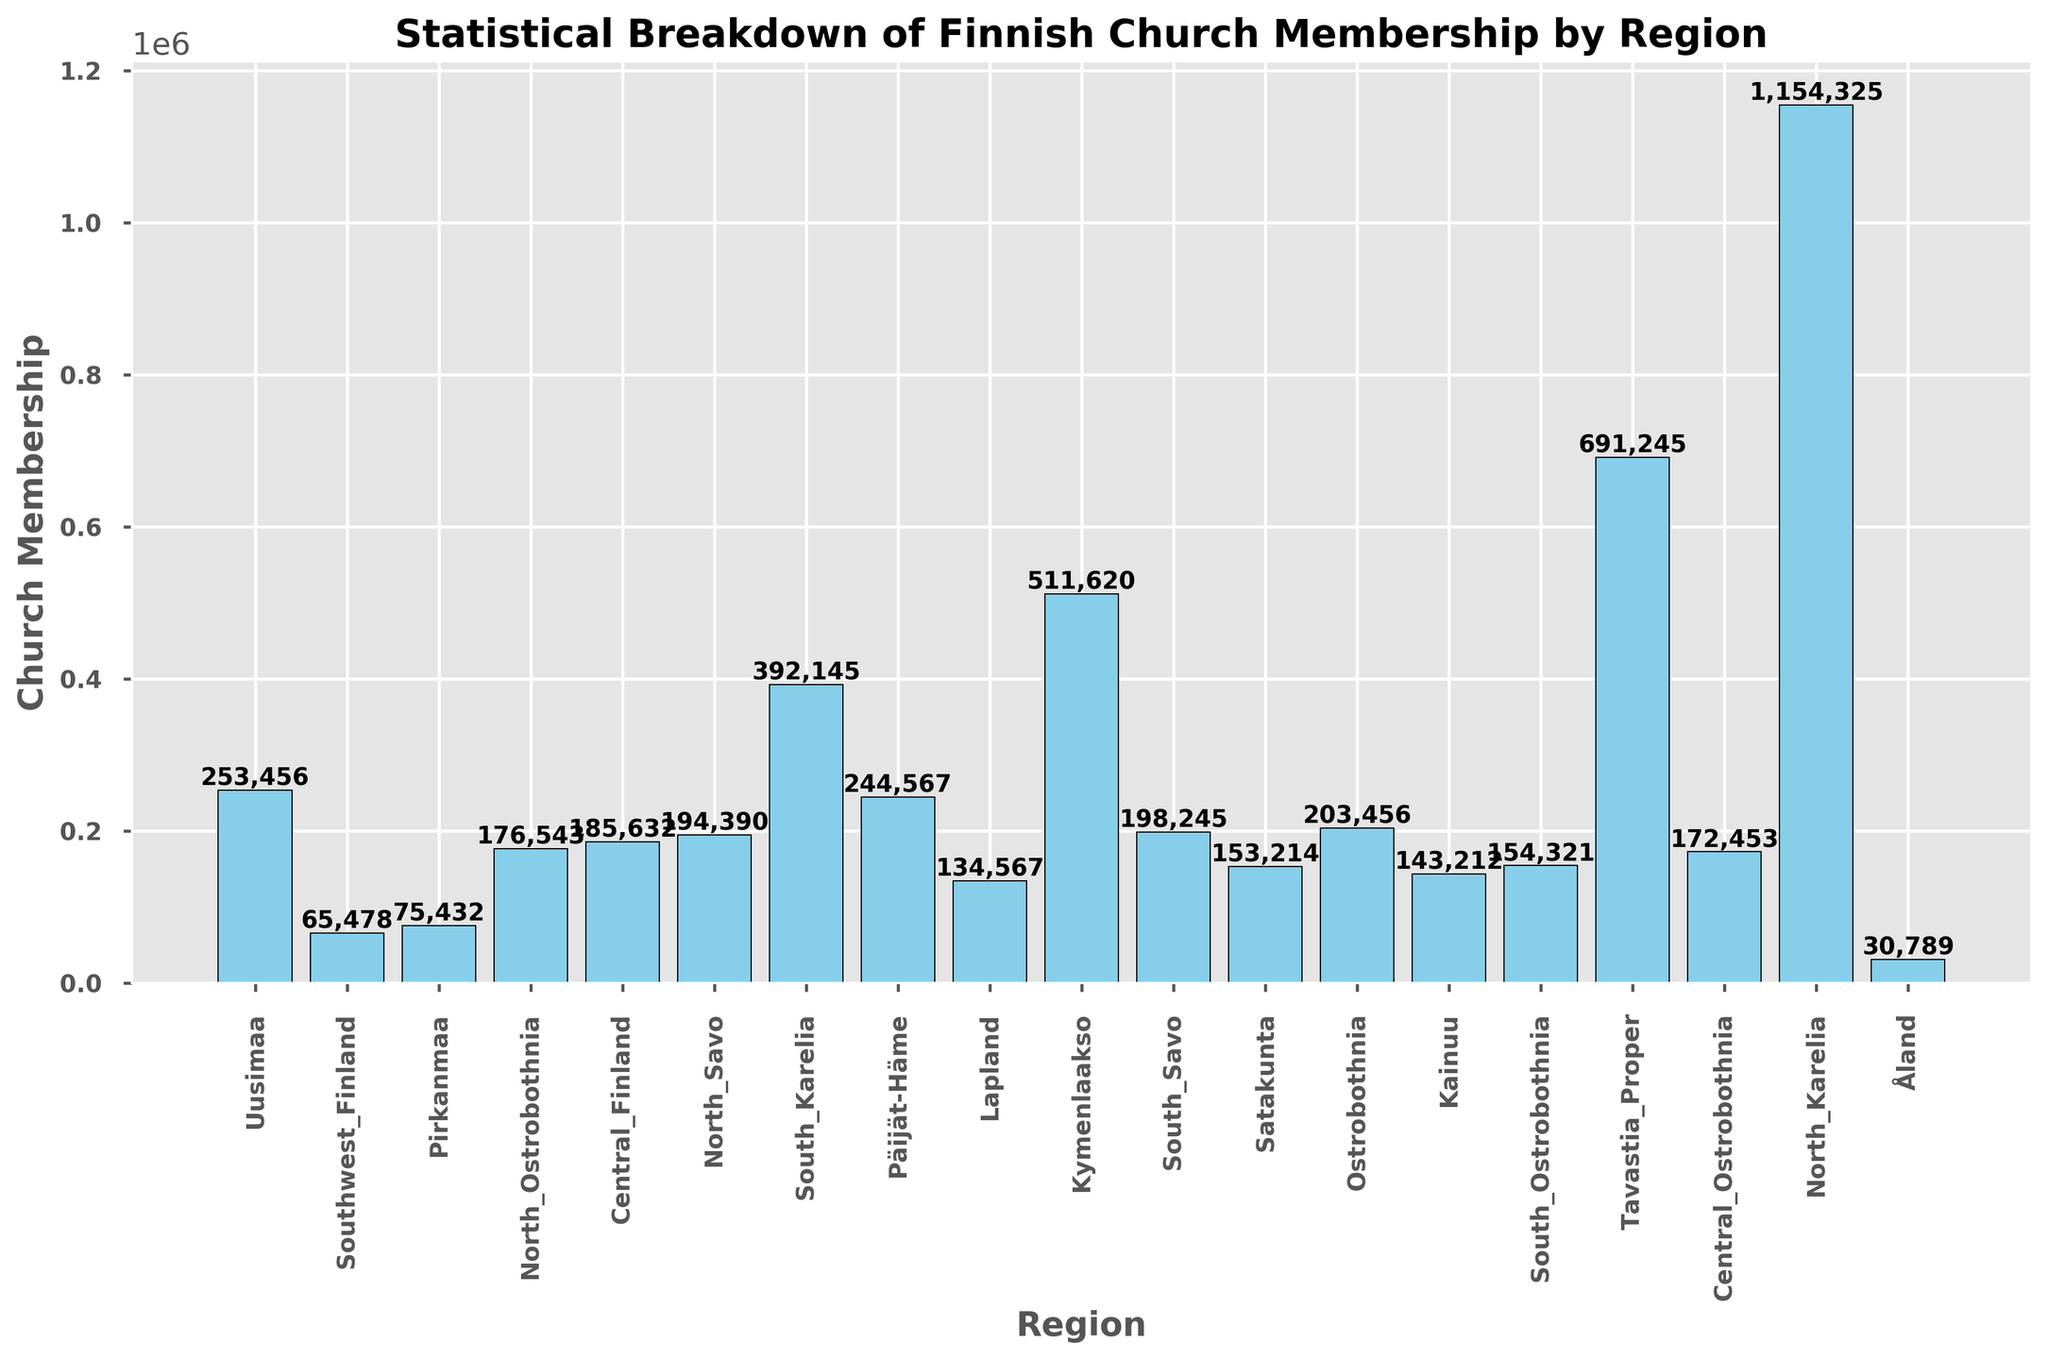Which region has the highest church membership? By observing the heights of the bars, we can see that the bar representing Uusimaa is the tallest, indicating the highest church membership.
Answer: Uusimaa Which region has the lowest church membership? By observing the heights of the bars, the bar representing Åland is the shortest, indicating the lowest church membership.
Answer: Åland What is the combined church membership of North Karelia and South Karelia? Adding the memberships of North Karelia (102,345 + 92,045) and South Karelia (203,456): 102,345 + 92,045 + 203,456 = 397,846.
Answer: 397,846 Is the church membership in Lapland higher or lower than in Kymenlaakso? By comparing the heights of the bars for Lapland and Kymenlaakso, it is evident that Lapland's bar is slightly higher than Kymenlaakso's.
Answer: Higher How does the church membership in Pirkanmaa compare to that in Southwest Finland? By comparing the heights of the bars, Pirkanmaa's bar is smaller than Southwest Finland's, indicating lower membership.
Answer: Lower Which regions have a church membership over 600,000? By observing the bars, only Uusimaa and Southwest Finland have memberships exceeding 600,000.
Answer: Uusimaa, Southwest Finland What is the difference in church membership between Central Finland and Päijät-Häme? Subtracting the membership of Päijät-Häme (198,245) from Central Finland (253,456): 253,456 - 198,245 = 55,211.
Answer: 55,211 What is the average church membership for the regions of Ostrobothnia, Central Ostrobothnia, and North Ostrobothnia? Summing memberships of Ostrobothnia (134,567), Central Ostrobothnia (65,478), and North Ostrobothnia (392,145) and dividing by 3: (134,567 + 65,478 + 392,145) / 3 = 592,190 / 3 = 197,397.
Answer: 197,397 Count the number of regions with church membership between 100,000 and 300,000. Counting the bars that fall in this range, which includes North Ostrobothnia, Central Finland, North Savo, South Karelia, Päijät-Häme, Lapland, Kymenlaakso, South Savo, Satakunta, South Ostrobothnia, Tavastia Proper, North Karelia, and North Karelia twice, summing to 13.
Answer: 13 